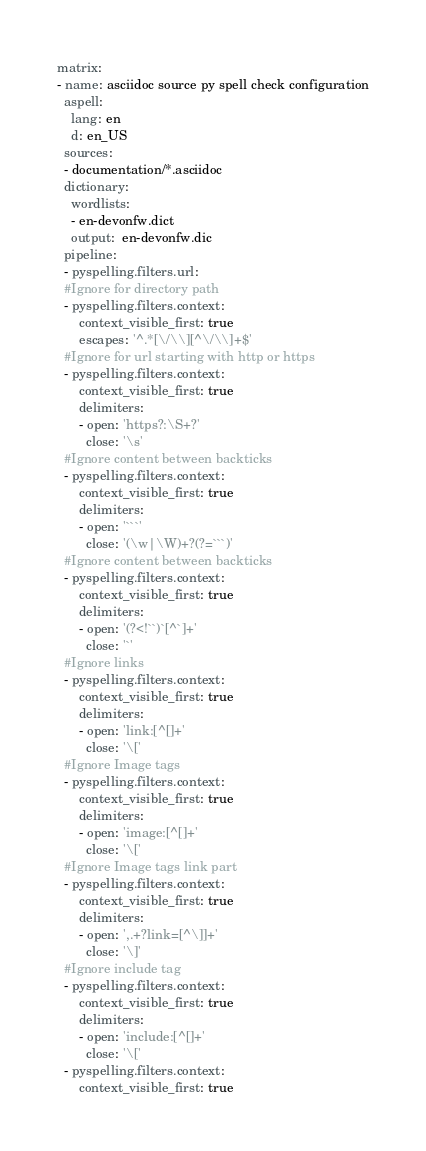Convert code to text. <code><loc_0><loc_0><loc_500><loc_500><_YAML_>matrix:
- name: asciidoc source py spell check configuration
  aspell:
    lang: en
    d: en_US
  sources:
  - documentation/*.asciidoc 
  dictionary:
    wordlists:
    - en-devonfw.dict
    output:  en-devonfw.dic
  pipeline:
  - pyspelling.filters.url:
  #Ignore for directory path
  - pyspelling.filters.context: 
      context_visible_first: true
      escapes: '^.*[\/\\][^\/\\]+$'
  #Ignore for url starting with http or https
  - pyspelling.filters.context: 
      context_visible_first: true
      delimiters:
      - open: 'https?:\S+?'
        close: '\s'
  #Ignore content between backticks
  - pyspelling.filters.context: 
      context_visible_first: true
      delimiters:
      - open: '```'
        close: '(\w|\W)+?(?=```)'
  #Ignore content between backticks
  - pyspelling.filters.context: 
      context_visible_first: true
      delimiters:
      - open: '(?<!``)`[^`]+'
        close: '`'
  #Ignore links
  - pyspelling.filters.context: 
      context_visible_first: true
      delimiters:
      - open: 'link:[^[]+'
        close: '\['
  #Ignore Image tags
  - pyspelling.filters.context: 
      context_visible_first: true
      delimiters:
      - open: 'image:[^[]+'
        close: '\['
  #Ignore Image tags link part
  - pyspelling.filters.context:
      context_visible_first: true
      delimiters:
      - open: ',.+?link=[^\]]+'
        close: '\]'
  #Ignore include tag
  - pyspelling.filters.context: 
      context_visible_first: true
      delimiters:
      - open: 'include:[^[]+'
        close: '\['
  - pyspelling.filters.context:
      context_visible_first: true</code> 